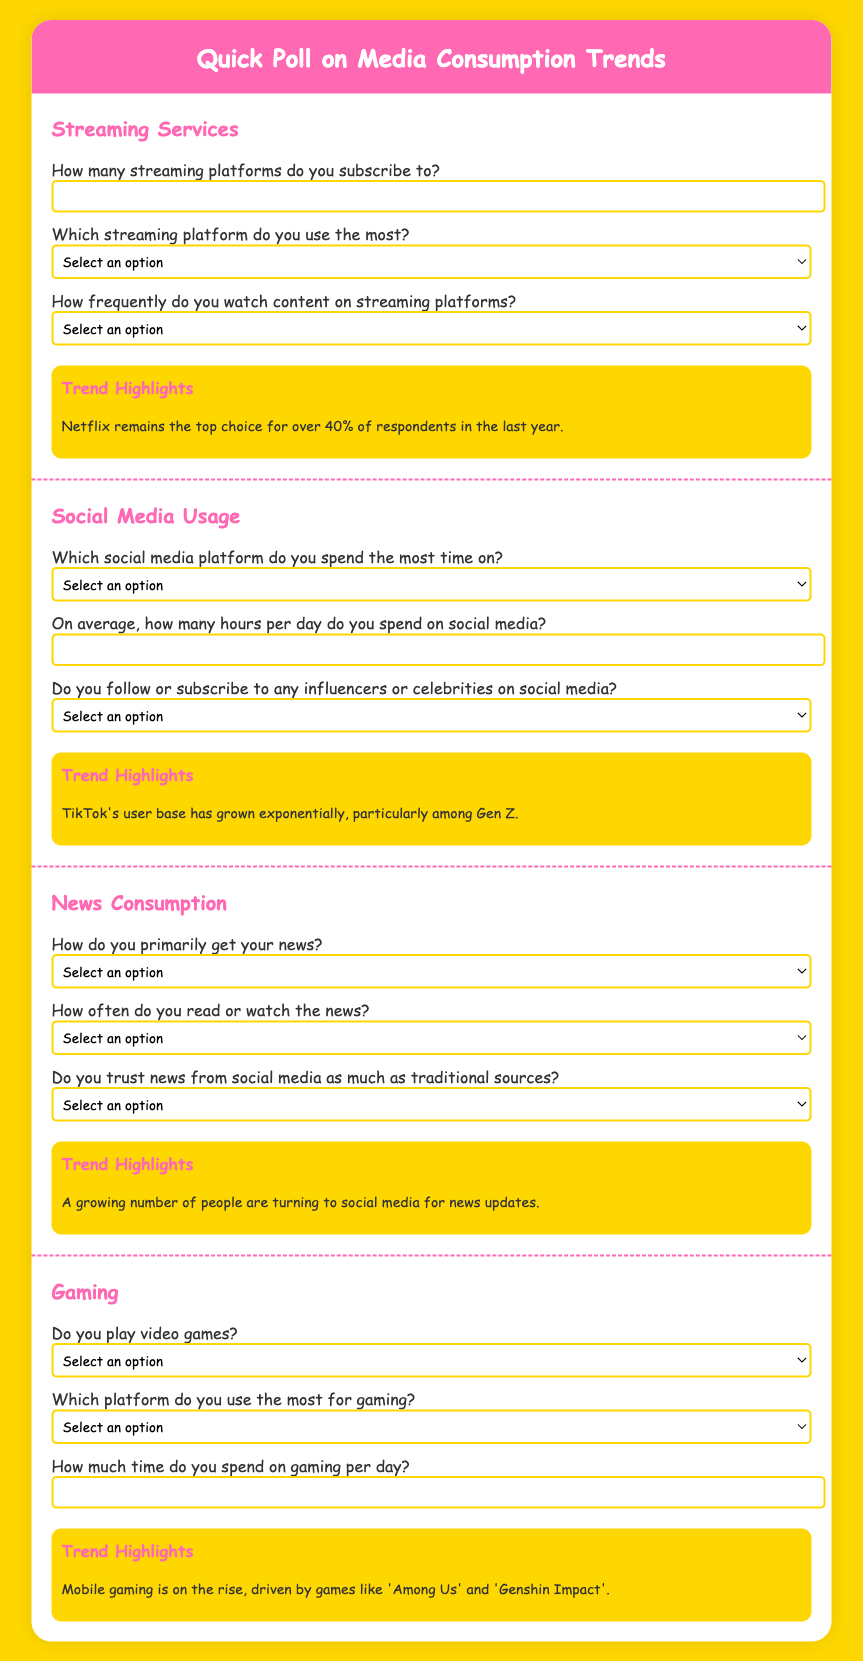What percentage of respondents prefer Netflix? The question queries for specific statistical information presented in the trend highlights regarding Netflix's popularity.
Answer: 40% Which social media platform has grown exponentially among Gen Z? This question focuses on a specific detail about social media trends highlighted in the document.
Answer: TikTok What is the primary source of news for this audience? This asks to identify the main way people get their news as described in the questionnaire.
Answer: Online news sites Do people trust news from social media as much as traditional sources? This question is looking for a yes or no answer regarding public trust in news sources mentioned in the document.
Answer: Yes What gaming platform is mentioned in the document? This asks for specific information regarding the platforms people use for gaming mentioned in the questionnaire.
Answer: PC What is the trend with mobile gaming? The question examines the overall direction of mobile gaming based on the document's trend highlights.
Answer: On the rise 